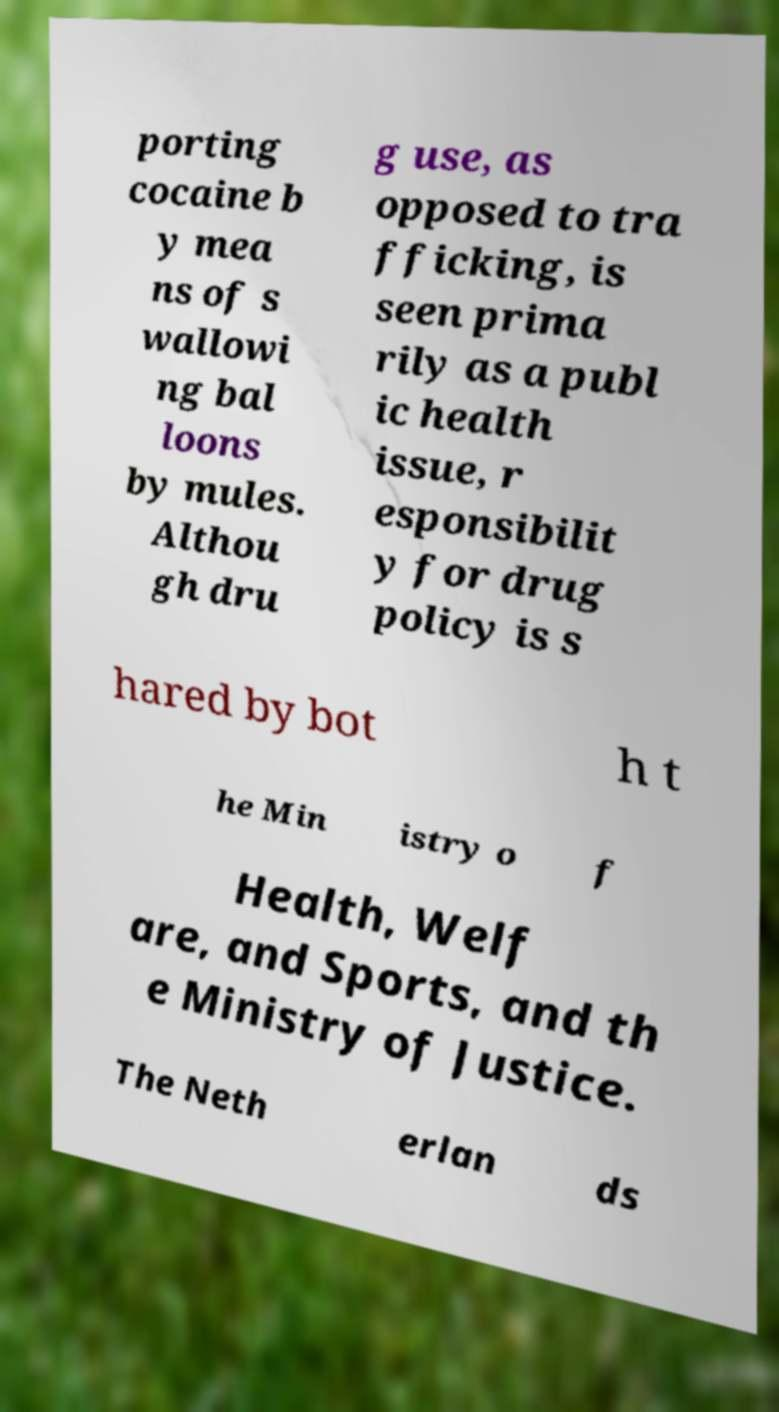Please read and relay the text visible in this image. What does it say? porting cocaine b y mea ns of s wallowi ng bal loons by mules. Althou gh dru g use, as opposed to tra fficking, is seen prima rily as a publ ic health issue, r esponsibilit y for drug policy is s hared by bot h t he Min istry o f Health, Welf are, and Sports, and th e Ministry of Justice. The Neth erlan ds 